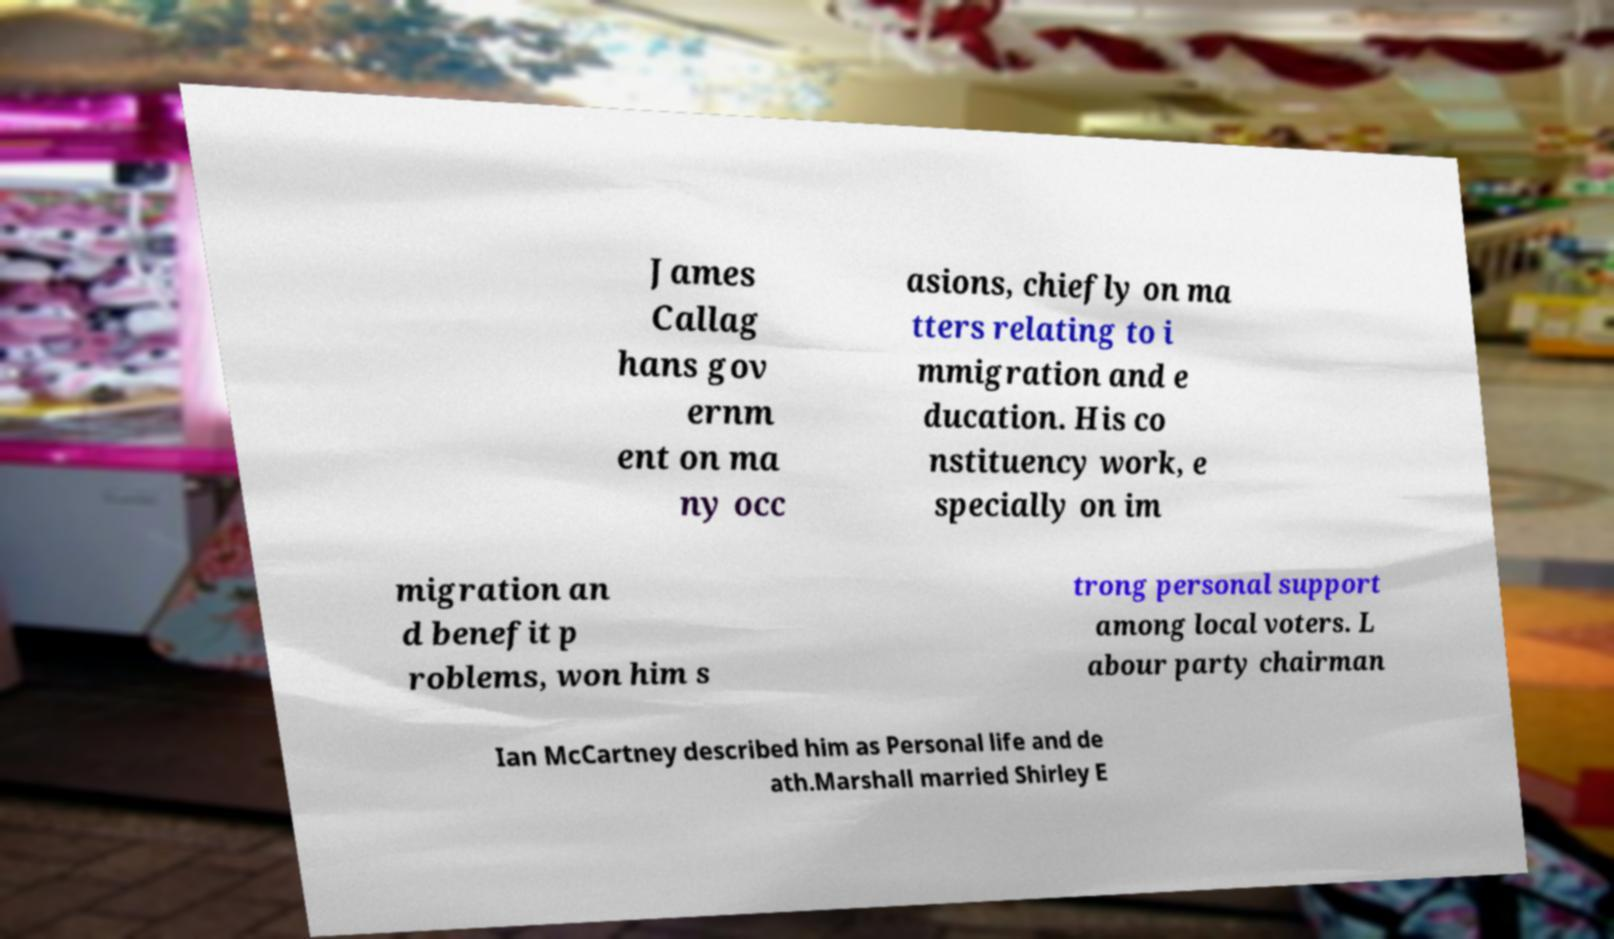Can you read and provide the text displayed in the image?This photo seems to have some interesting text. Can you extract and type it out for me? James Callag hans gov ernm ent on ma ny occ asions, chiefly on ma tters relating to i mmigration and e ducation. His co nstituency work, e specially on im migration an d benefit p roblems, won him s trong personal support among local voters. L abour party chairman Ian McCartney described him as Personal life and de ath.Marshall married Shirley E 